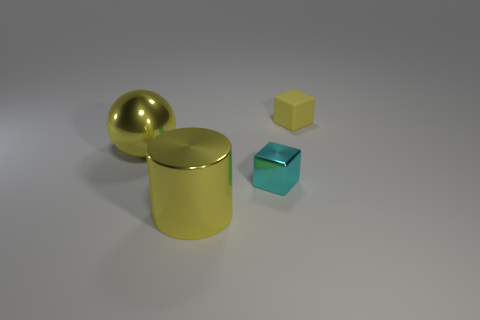Add 3 purple matte cylinders. How many objects exist? 7 Subtract all balls. How many objects are left? 3 Add 4 matte cubes. How many matte cubes are left? 5 Add 1 rubber objects. How many rubber objects exist? 2 Subtract all cyan blocks. How many blocks are left? 1 Subtract 0 purple cylinders. How many objects are left? 4 Subtract 1 cylinders. How many cylinders are left? 0 Subtract all cyan spheres. Subtract all red blocks. How many spheres are left? 1 Subtract all small yellow rubber things. Subtract all small yellow rubber things. How many objects are left? 2 